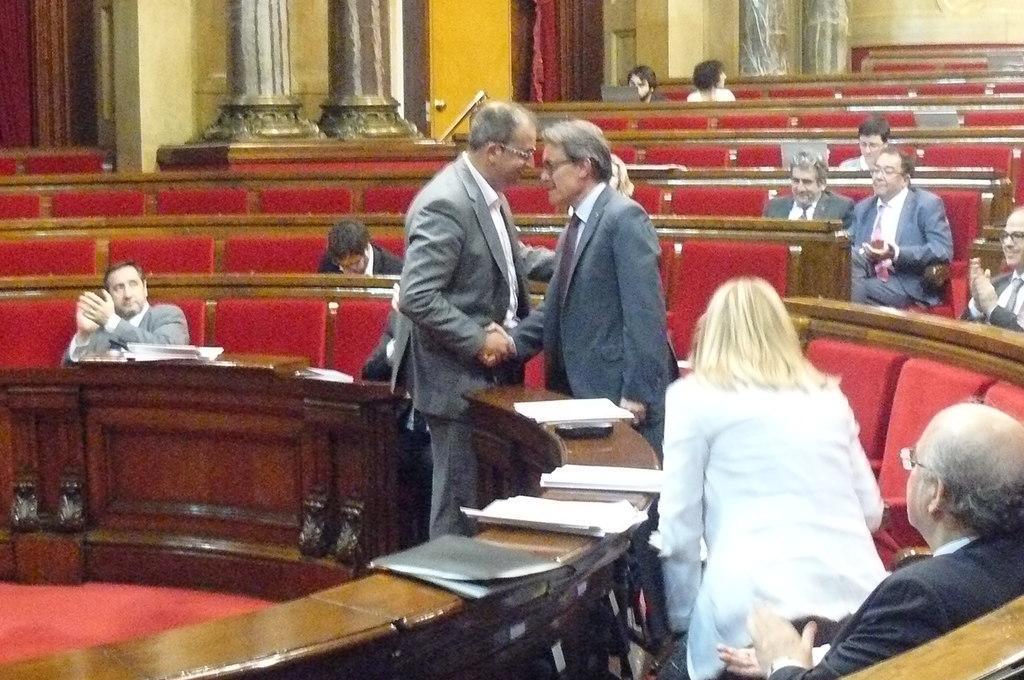Could you give a brief overview of what you see in this image? In this image, we can see some people sitting, and some are standing and there are papers on the table. In the background, there are pillars. 